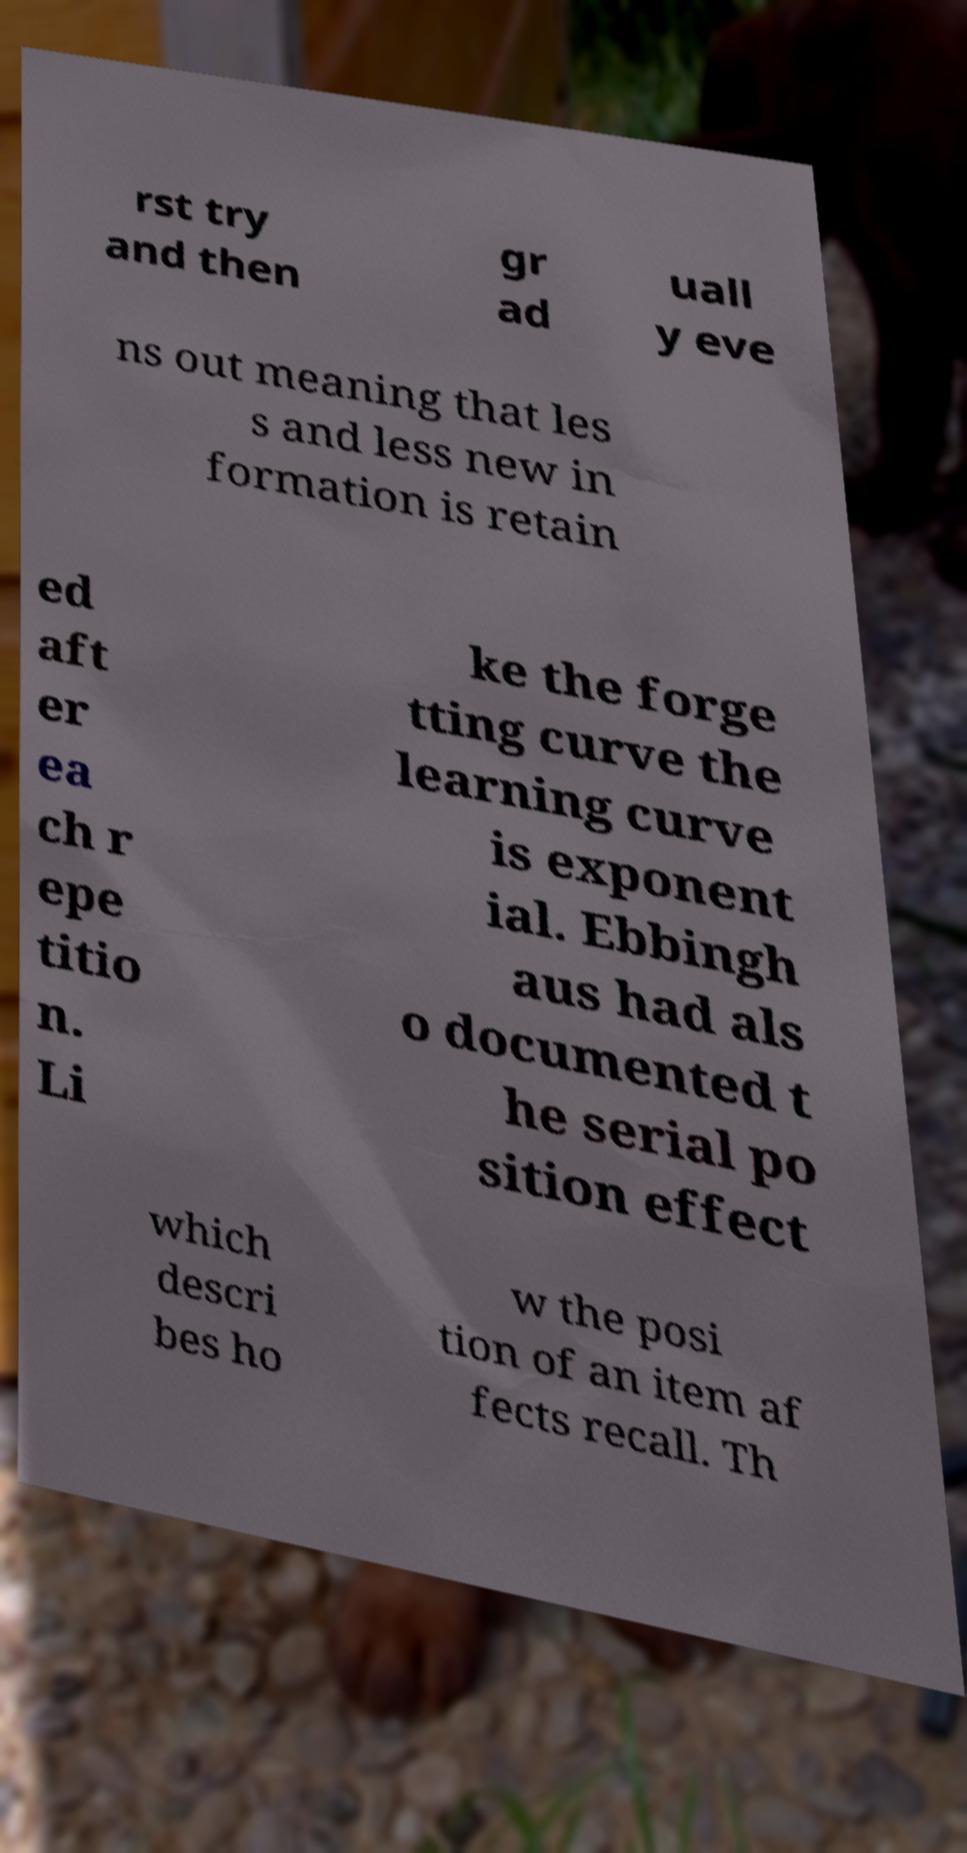Could you assist in decoding the text presented in this image and type it out clearly? rst try and then gr ad uall y eve ns out meaning that les s and less new in formation is retain ed aft er ea ch r epe titio n. Li ke the forge tting curve the learning curve is exponent ial. Ebbingh aus had als o documented t he serial po sition effect which descri bes ho w the posi tion of an item af fects recall. Th 